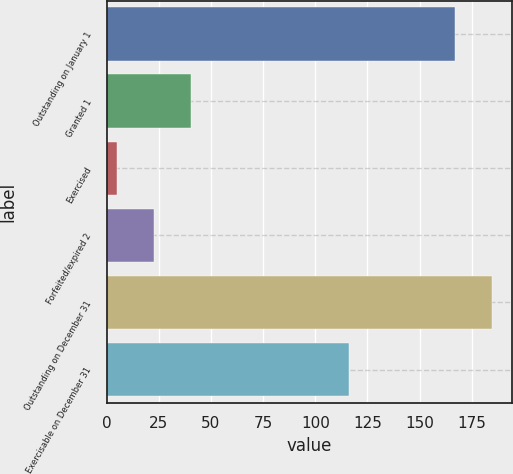Convert chart. <chart><loc_0><loc_0><loc_500><loc_500><bar_chart><fcel>Outstanding on January 1<fcel>Granted 1<fcel>Exercised<fcel>Forfeited/expired 2<fcel>Outstanding on December 31<fcel>Exercisable on December 31<nl><fcel>167<fcel>40.6<fcel>5<fcel>22.8<fcel>184.8<fcel>116<nl></chart> 